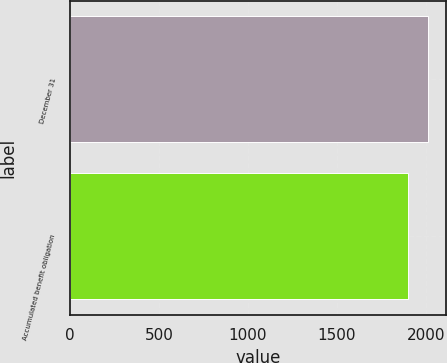Convert chart. <chart><loc_0><loc_0><loc_500><loc_500><bar_chart><fcel>December 31<fcel>Accumulated benefit obligation<nl><fcel>2013<fcel>1900<nl></chart> 